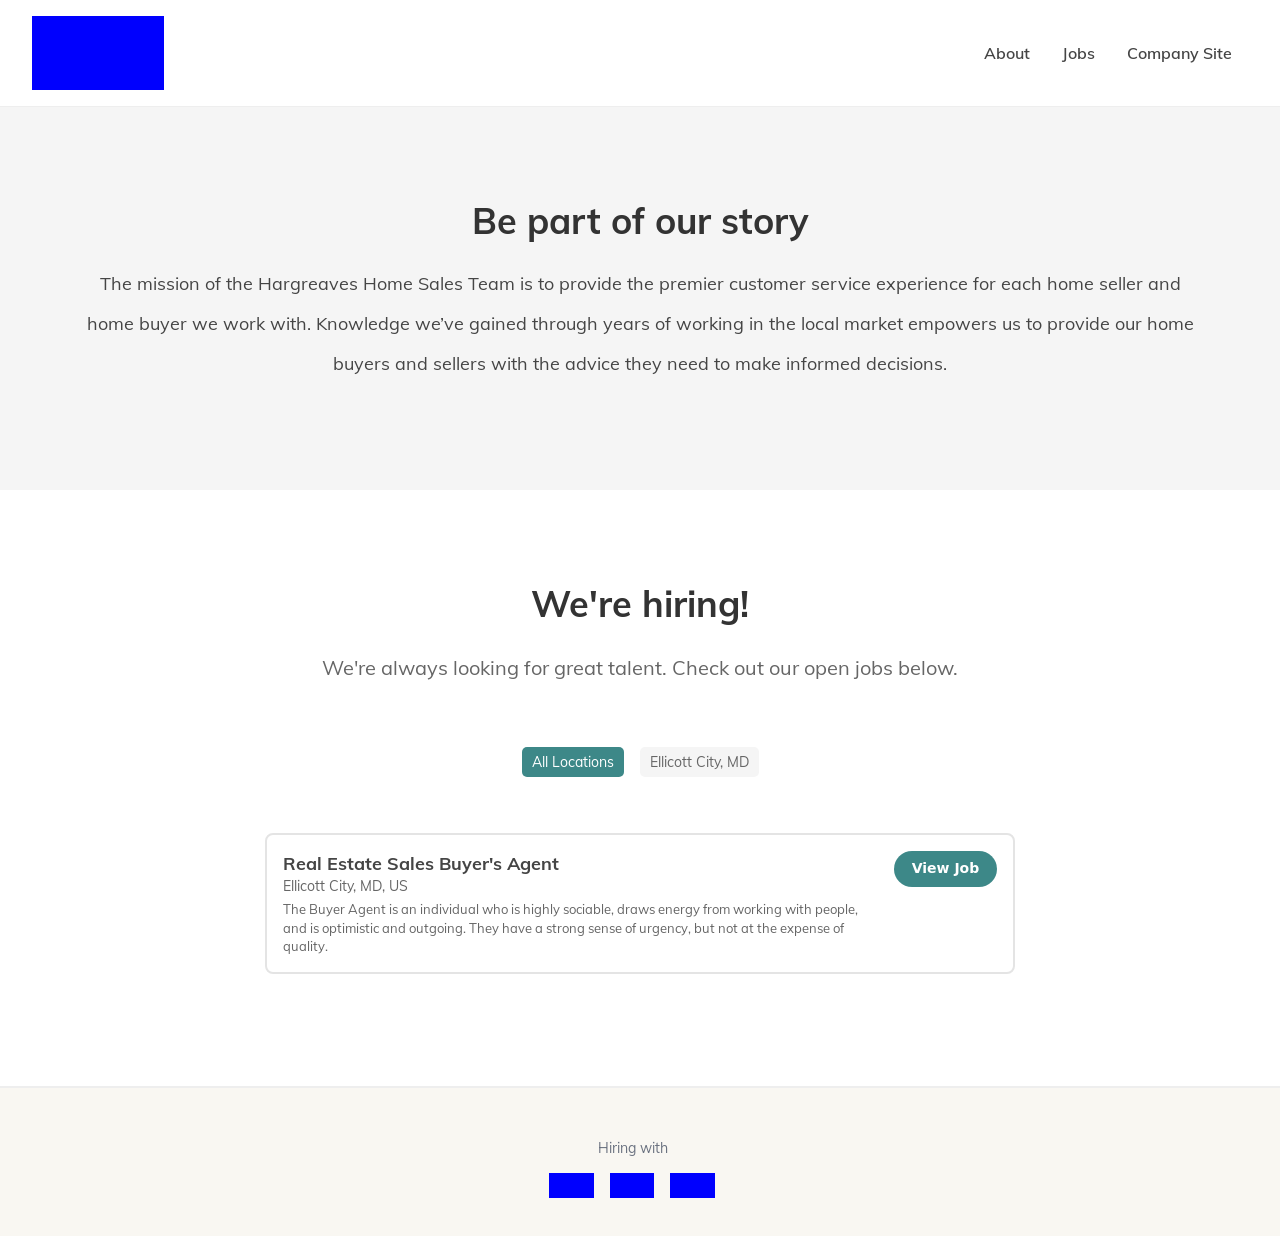How can I start building this website with HTML from the ground up? To start building a website like the one shown in the image, you'll first want to create a basic HTML structure. Here's a simplified version to get you started:

<!DOCTYPE html>
<html>
<head>
    <title>Your Real Estate Site</title>
</head>
<body>
    <header>
        <h1>Welcome to Our Real Estate Agency</h1>
        <nav>
            <a href='#about'>About</a>
            <a href='#jobs'>Jobs</a>
            <a href='#contact'>Contact</a>
        </nav>
    </header>
    <section id='about'>
        <h2>Be part of our story</h2>
        <p>The mission of our Home Sales Team is to provide excellent service...</p>
    </section>
    <section id='jobs'>
        <h2>We're hiring!</h2>
        <p>Check out our open jobs below.</p>
    </section>
    <footer>
        <p>Contact us</p>
    </footer>
</body>
</html>

This basic structure lays out the main sections shown in the image, which you can then style and expand as needed. 